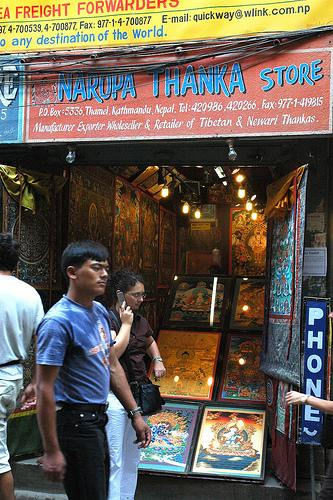In your own words, explain the key features of the man wearing a white shirt. The man has black hair, is wearing white shorts, and is walking by an art store. Describe the emotions or sentiment that can be inferred from the image. The sentiment in the image is relaxed and casual, as people are walking by a store and engaging in their own activities. Identify the objects attached to the person wearing a blue shirt and provide their properties. The person wearing a blue shirt is wearing black pants and a blue watch, and is also wearing a belt. How many total objects can be found in the image? Count only distinct objects. 15 List any notable signs and text found in the image, and what they mean if applicable. 4. Red sign with telephone number: another point of contact for the store Analyze the quality of the image based on the object details provided above: is it high, medium, or low quality? Medium quality. Though the objects are described, the details and precision of the positions and sizes might be somewhat inaccurate. Using simple sentences, enumerate the different art-related objects displayed in the store. There are 6 art works, a painting of Buddha, and 1 colorful painting with a black frame on display. What is the color of the pants worn by the woman in the image? White Please provide a short summary of the scene in the image. People are walking by a store displaying art for sale, while a woman talks on her cellphone and a man wears a watch. Describe the interaction between the woman with a cellphone and another person, if any. There is no direct interaction between the woman with the cellphone and another person. 